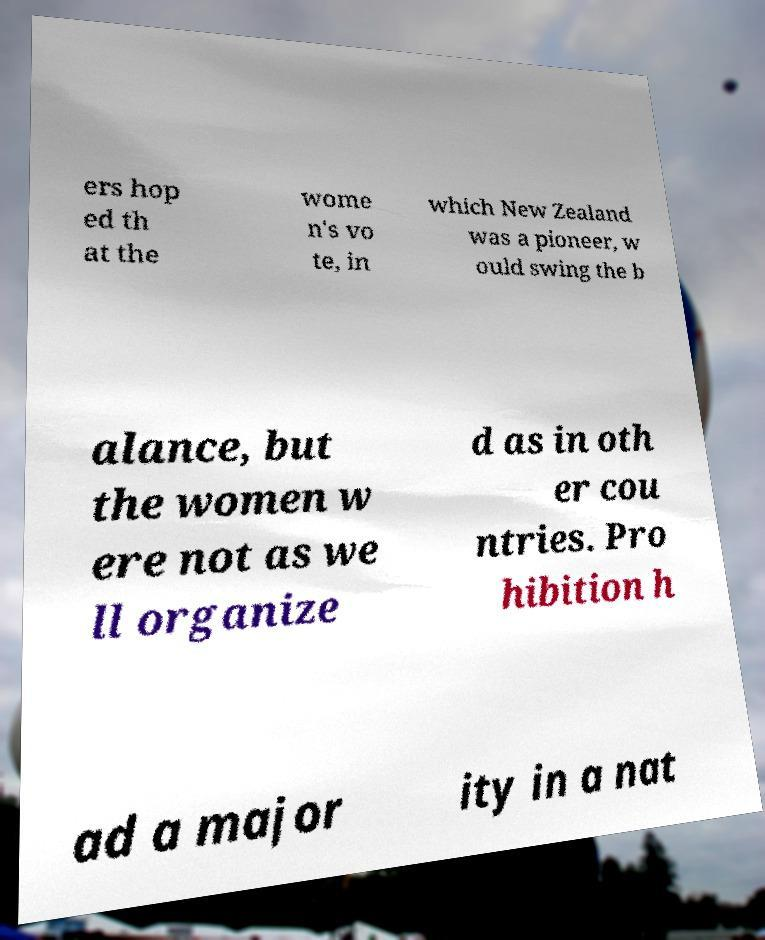Please identify and transcribe the text found in this image. ers hop ed th at the wome n's vo te, in which New Zealand was a pioneer, w ould swing the b alance, but the women w ere not as we ll organize d as in oth er cou ntries. Pro hibition h ad a major ity in a nat 